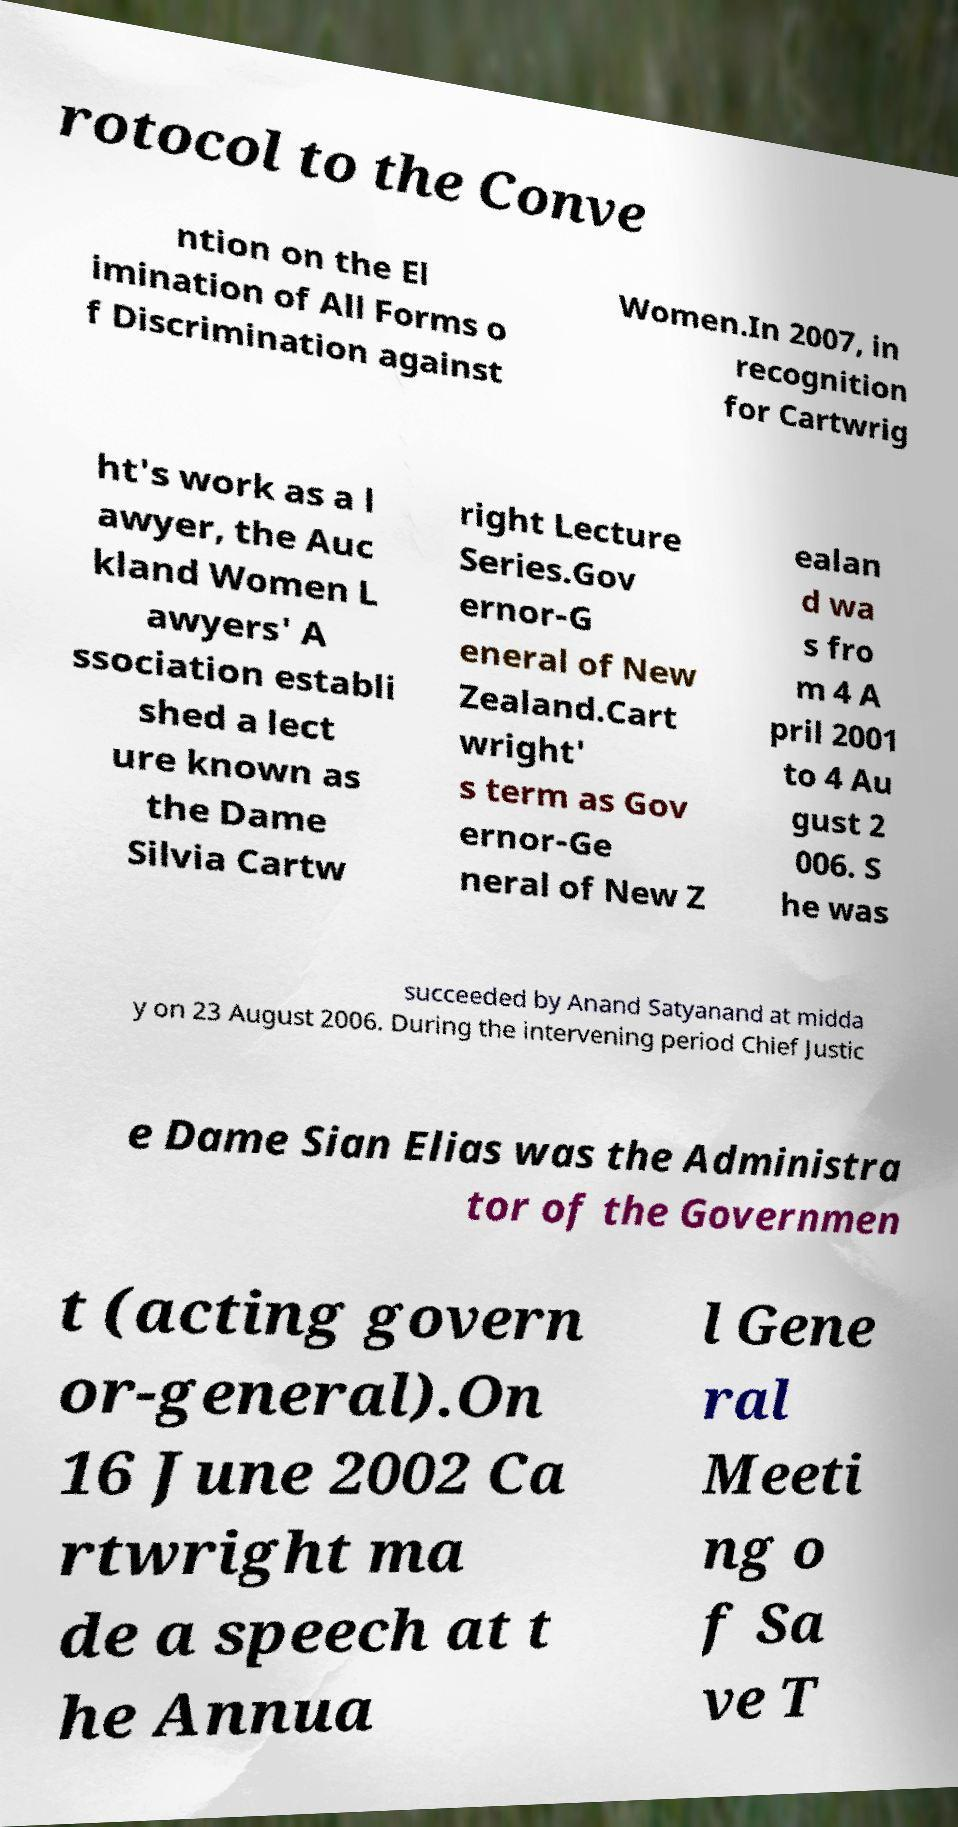Could you extract and type out the text from this image? rotocol to the Conve ntion on the El imination of All Forms o f Discrimination against Women.In 2007, in recognition for Cartwrig ht's work as a l awyer, the Auc kland Women L awyers' A ssociation establi shed a lect ure known as the Dame Silvia Cartw right Lecture Series.Gov ernor-G eneral of New Zealand.Cart wright' s term as Gov ernor-Ge neral of New Z ealan d wa s fro m 4 A pril 2001 to 4 Au gust 2 006. S he was succeeded by Anand Satyanand at midda y on 23 August 2006. During the intervening period Chief Justic e Dame Sian Elias was the Administra tor of the Governmen t (acting govern or-general).On 16 June 2002 Ca rtwright ma de a speech at t he Annua l Gene ral Meeti ng o f Sa ve T 